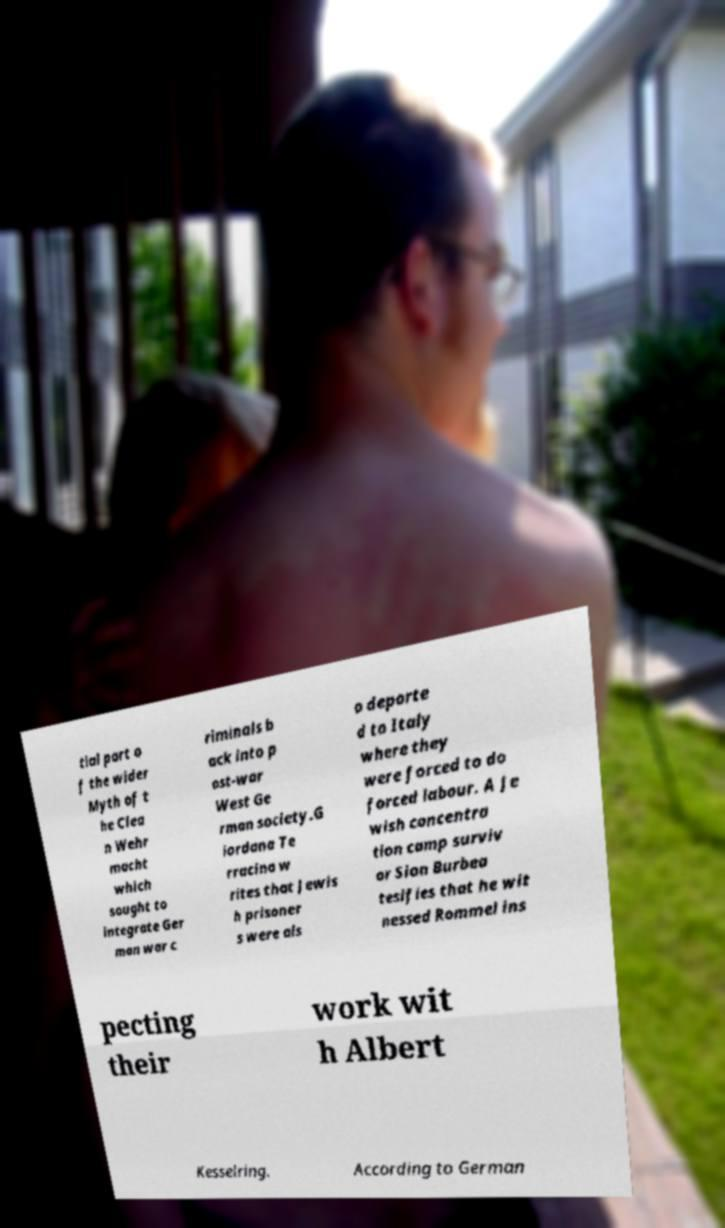Can you accurately transcribe the text from the provided image for me? tial part o f the wider Myth of t he Clea n Wehr macht which sought to integrate Ger man war c riminals b ack into p ost-war West Ge rman society.G iordana Te rracina w rites that Jewis h prisoner s were als o deporte d to Italy where they were forced to do forced labour. A Je wish concentra tion camp surviv or Sion Burbea tesifies that he wit nessed Rommel ins pecting their work wit h Albert Kesselring. According to German 